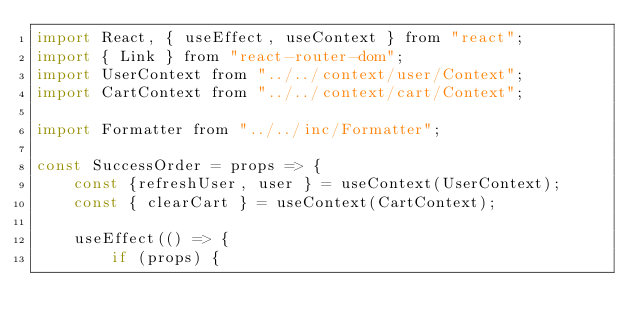Convert code to text. <code><loc_0><loc_0><loc_500><loc_500><_JavaScript_>import React, { useEffect, useContext } from "react";
import { Link } from "react-router-dom";
import UserContext from "../../context/user/Context";
import CartContext from "../../context/cart/Context";

import Formatter from "../../inc/Formatter";

const SuccessOrder = props => {
    const {refreshUser, user } = useContext(UserContext);
    const { clearCart } = useContext(CartContext);

    useEffect(() => {
        if (props) {</code> 